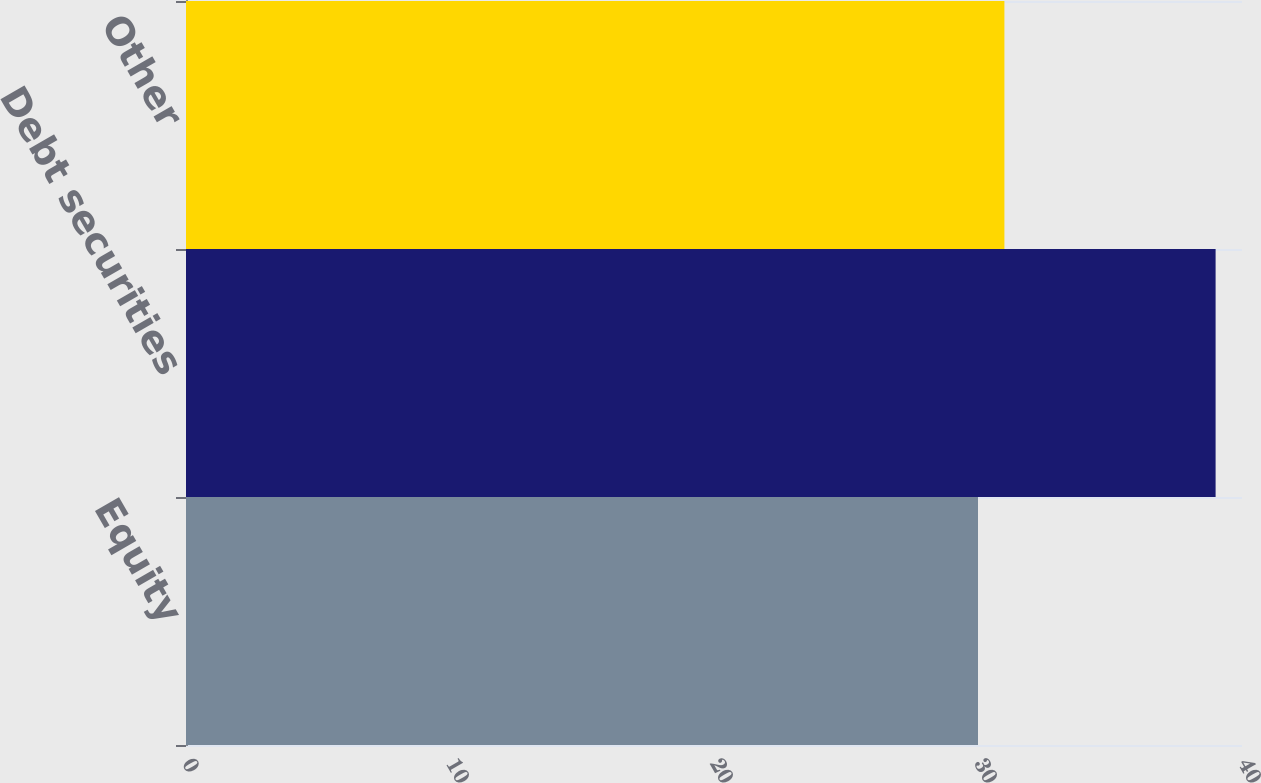Convert chart. <chart><loc_0><loc_0><loc_500><loc_500><bar_chart><fcel>Equity<fcel>Debt securities<fcel>Other<nl><fcel>30<fcel>39<fcel>31<nl></chart> 